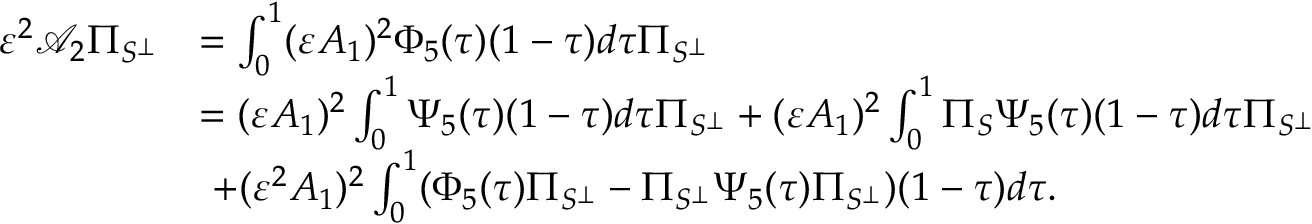Convert formula to latex. <formula><loc_0><loc_0><loc_500><loc_500>\begin{array} { r l } { \varepsilon ^ { 2 } \mathcal { A } _ { 2 } \Pi _ { S ^ { \perp } } } & { = \int _ { 0 } ^ { 1 } ( \varepsilon A _ { 1 } ) ^ { 2 } \Phi _ { 5 } ( \tau ) ( 1 - \tau ) d \tau \Pi _ { S ^ { \perp } } } \\ & { = ( \varepsilon A _ { 1 } ) ^ { 2 } \int _ { 0 } ^ { 1 } \Psi _ { 5 } ( \tau ) ( 1 - \tau ) d \tau \Pi _ { S ^ { \perp } } + ( \varepsilon A _ { 1 } ) ^ { 2 } \int _ { 0 } ^ { 1 } \Pi _ { S } \Psi _ { 5 } ( \tau ) ( 1 - \tau ) d \tau \Pi _ { S ^ { \perp } } } \\ & { \ + ( \varepsilon ^ { 2 } A _ { 1 } ) ^ { 2 } \int _ { 0 } ^ { 1 } ( \Phi _ { 5 } ( \tau ) \Pi _ { S ^ { \perp } } - \Pi _ { S ^ { \perp } } \Psi _ { 5 } ( \tau ) \Pi _ { S ^ { \perp } } ) ( 1 - \tau ) d \tau . } \end{array}</formula> 